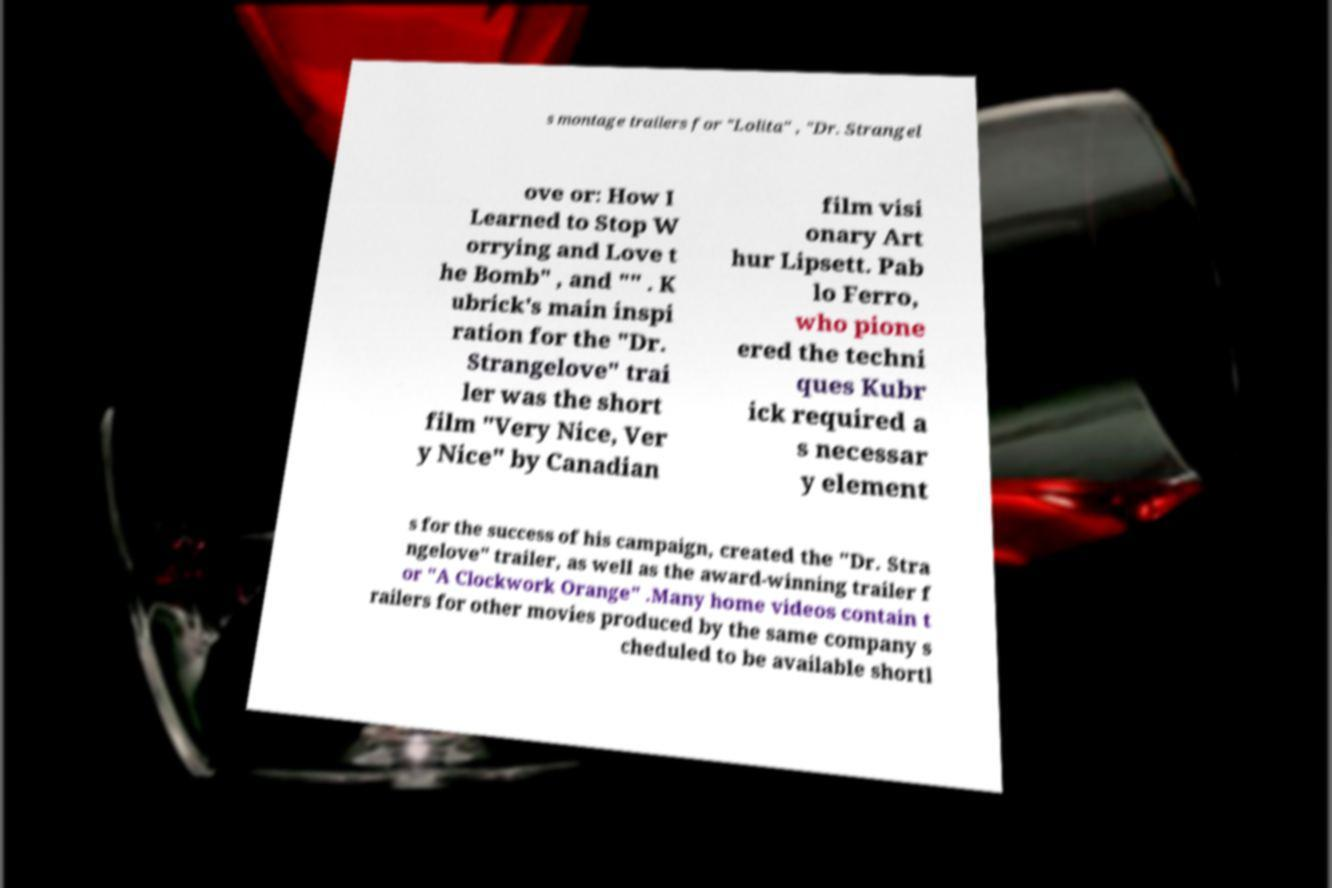Can you accurately transcribe the text from the provided image for me? s montage trailers for "Lolita" , "Dr. Strangel ove or: How I Learned to Stop W orrying and Love t he Bomb" , and "" . K ubrick's main inspi ration for the "Dr. Strangelove" trai ler was the short film "Very Nice, Ver y Nice" by Canadian film visi onary Art hur Lipsett. Pab lo Ferro, who pione ered the techni ques Kubr ick required a s necessar y element s for the success of his campaign, created the "Dr. Stra ngelove" trailer, as well as the award-winning trailer f or "A Clockwork Orange" .Many home videos contain t railers for other movies produced by the same company s cheduled to be available shortl 